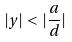Convert formula to latex. <formula><loc_0><loc_0><loc_500><loc_500>| y | < | \frac { a } { d } |</formula> 